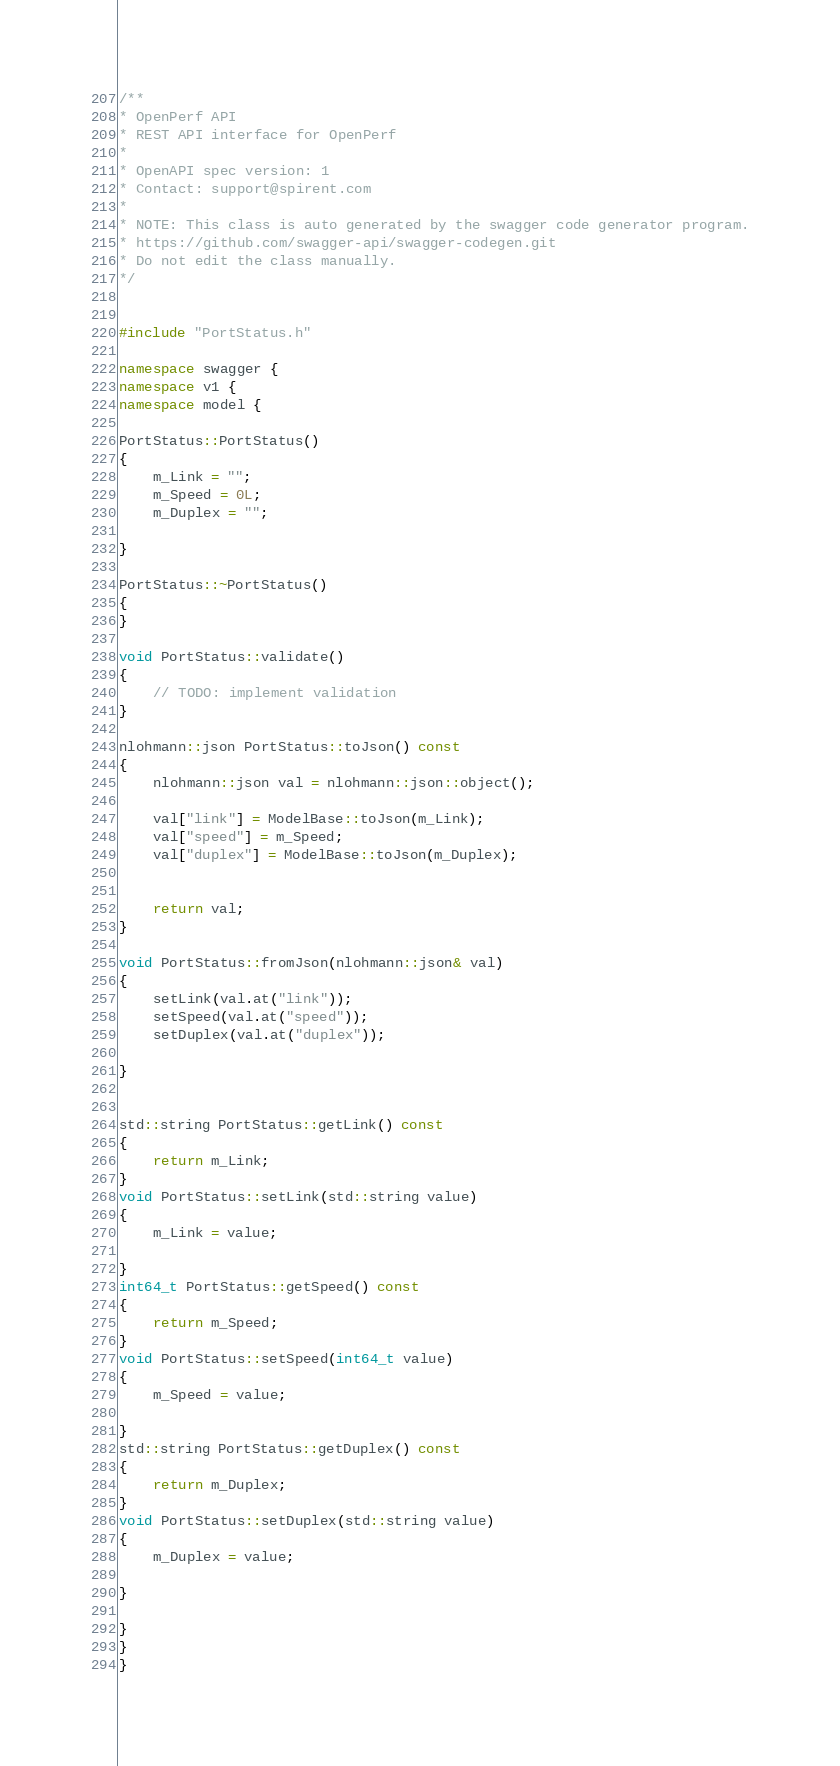Convert code to text. <code><loc_0><loc_0><loc_500><loc_500><_C++_>/**
* OpenPerf API
* REST API interface for OpenPerf
*
* OpenAPI spec version: 1
* Contact: support@spirent.com
*
* NOTE: This class is auto generated by the swagger code generator program.
* https://github.com/swagger-api/swagger-codegen.git
* Do not edit the class manually.
*/


#include "PortStatus.h"

namespace swagger {
namespace v1 {
namespace model {

PortStatus::PortStatus()
{
    m_Link = "";
    m_Speed = 0L;
    m_Duplex = "";
    
}

PortStatus::~PortStatus()
{
}

void PortStatus::validate()
{
    // TODO: implement validation
}

nlohmann::json PortStatus::toJson() const
{
    nlohmann::json val = nlohmann::json::object();

    val["link"] = ModelBase::toJson(m_Link);
    val["speed"] = m_Speed;
    val["duplex"] = ModelBase::toJson(m_Duplex);
    

    return val;
}

void PortStatus::fromJson(nlohmann::json& val)
{
    setLink(val.at("link"));
    setSpeed(val.at("speed"));
    setDuplex(val.at("duplex"));
    
}


std::string PortStatus::getLink() const
{
    return m_Link;
}
void PortStatus::setLink(std::string value)
{
    m_Link = value;
    
}
int64_t PortStatus::getSpeed() const
{
    return m_Speed;
}
void PortStatus::setSpeed(int64_t value)
{
    m_Speed = value;
    
}
std::string PortStatus::getDuplex() const
{
    return m_Duplex;
}
void PortStatus::setDuplex(std::string value)
{
    m_Duplex = value;
    
}

}
}
}

</code> 